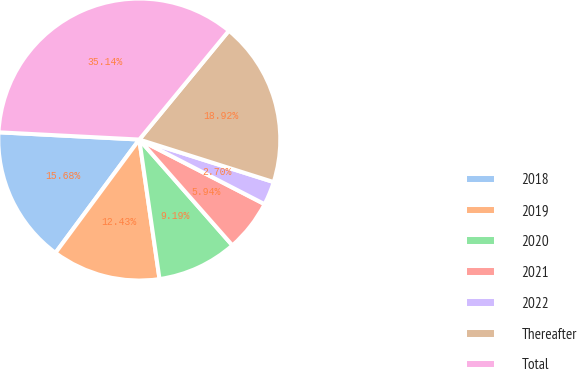Convert chart. <chart><loc_0><loc_0><loc_500><loc_500><pie_chart><fcel>2018<fcel>2019<fcel>2020<fcel>2021<fcel>2022<fcel>Thereafter<fcel>Total<nl><fcel>15.68%<fcel>12.43%<fcel>9.19%<fcel>5.94%<fcel>2.7%<fcel>18.92%<fcel>35.14%<nl></chart> 